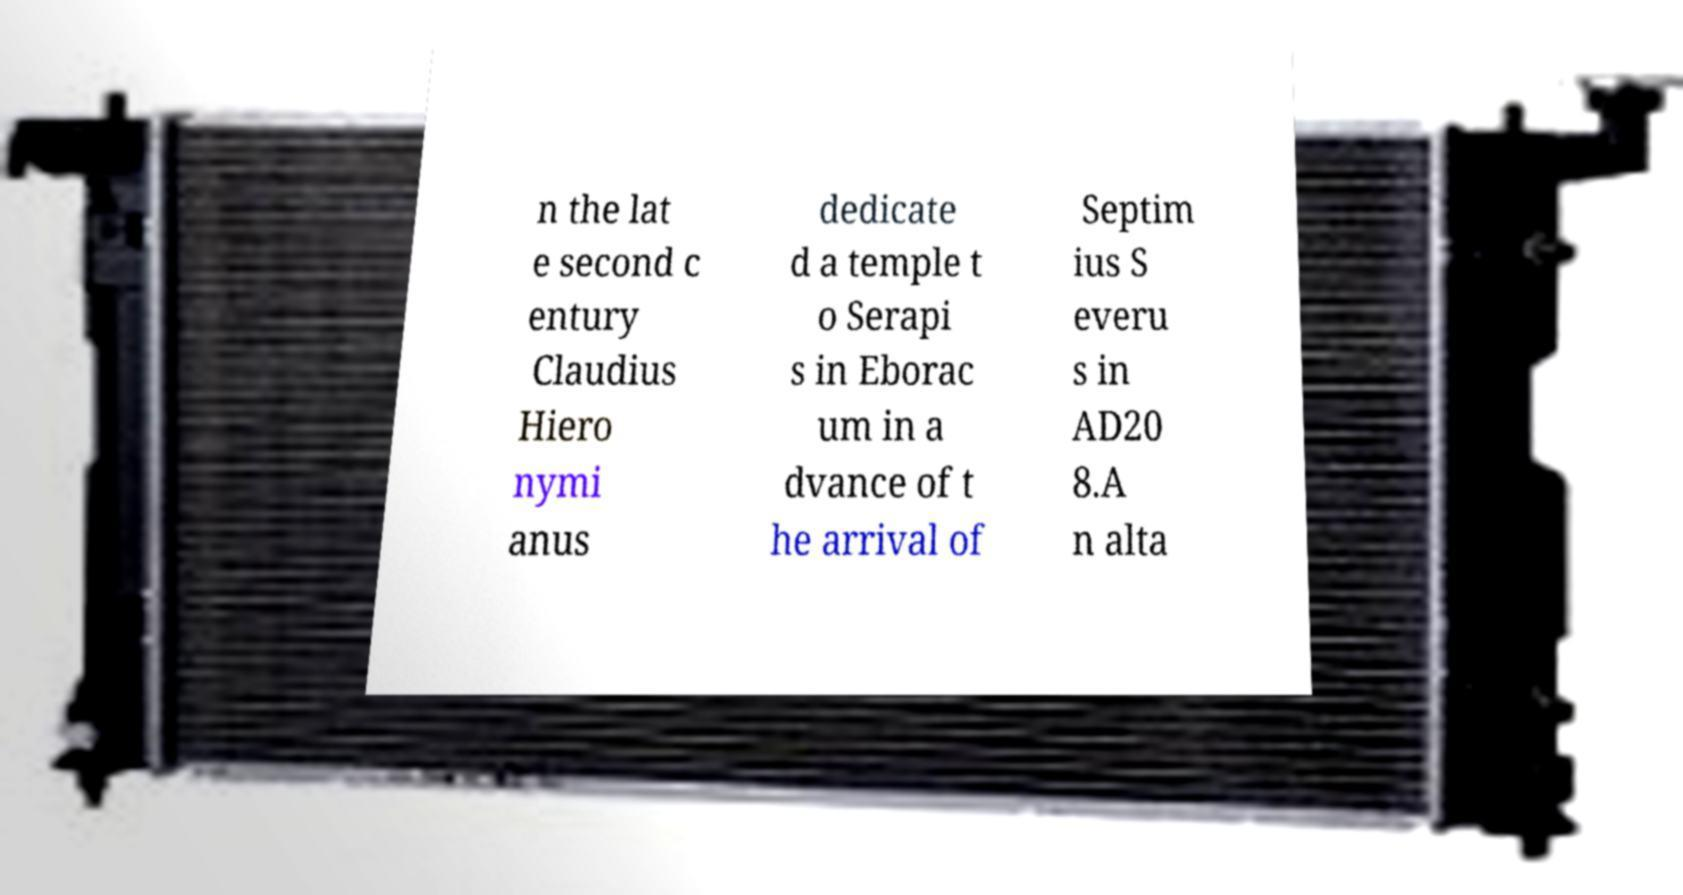Please read and relay the text visible in this image. What does it say? n the lat e second c entury Claudius Hiero nymi anus dedicate d a temple t o Serapi s in Eborac um in a dvance of t he arrival of Septim ius S everu s in AD20 8.A n alta 